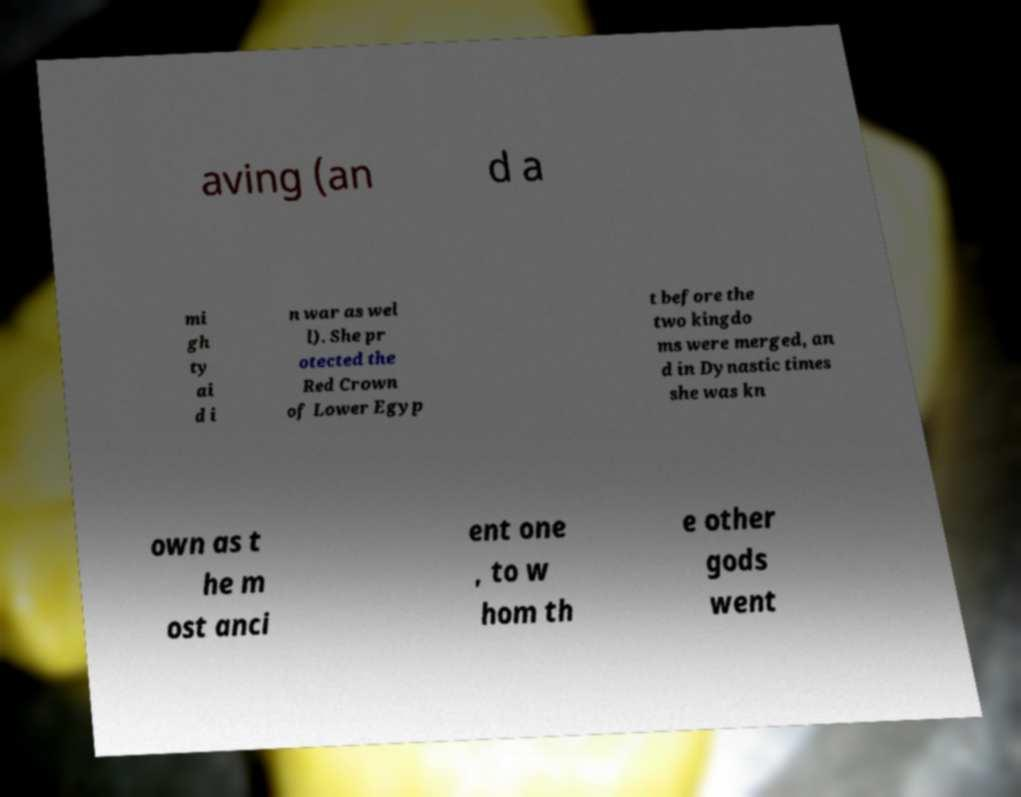What messages or text are displayed in this image? I need them in a readable, typed format. aving (an d a mi gh ty ai d i n war as wel l). She pr otected the Red Crown of Lower Egyp t before the two kingdo ms were merged, an d in Dynastic times she was kn own as t he m ost anci ent one , to w hom th e other gods went 